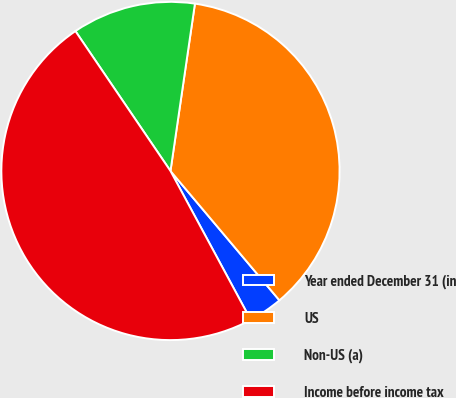Convert chart. <chart><loc_0><loc_0><loc_500><loc_500><pie_chart><fcel>Year ended December 31 (in<fcel>US<fcel>Non-US (a)<fcel>Income before income tax<nl><fcel>3.27%<fcel>36.55%<fcel>11.81%<fcel>48.37%<nl></chart> 